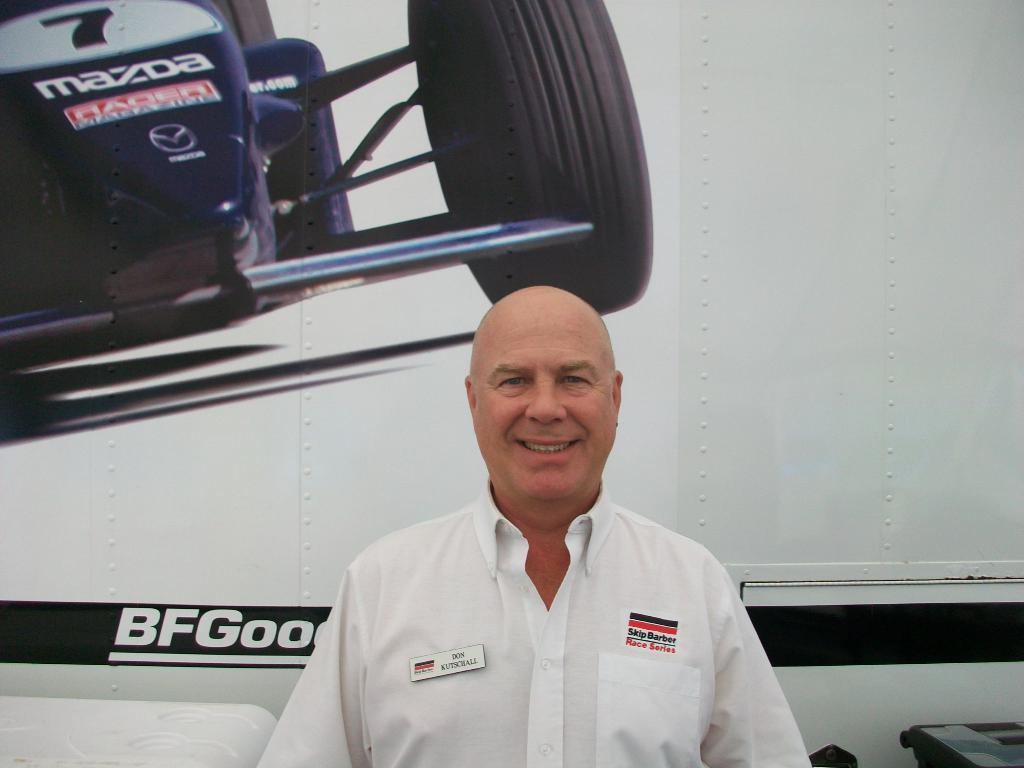What car company manufactured the race car?
Make the answer very short. Mazda. What number is on the cars hood?
Provide a succinct answer. 7. 